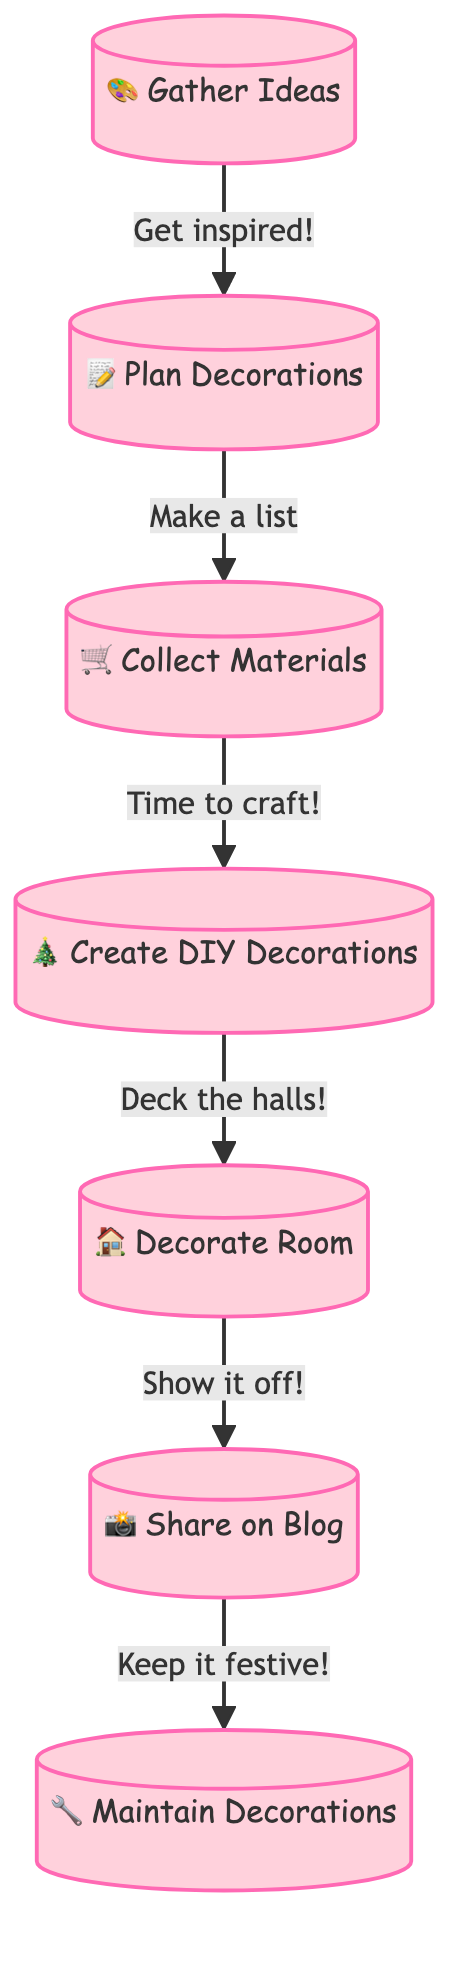What is the first step in the DIY room decoration process? The first block in the diagram is labeled "Gather Ideas," indicating this is the first step in the process.
Answer: Gather Ideas How many blocks are in the diagram? By counting the blocks listed in the data, there are a total of seven blocks showing different stages of the decoration process.
Answer: 7 What action follows "Collect Materials"? Looking at the transitions from one block to another, the action that follows "Collect Materials" is "Create DIY Decorations."
Answer: Create DIY Decorations Which block is directly connected to "Share on Blog"? "Share on Blog" is directly connected to "Maintain Decorations," as indicated by the transition leading from the former to the latter.
Answer: Maintain Decorations What is the last action in the DIY room decoration process? The last action in the block diagram is "Maintain Decorations," which shows it is the final step in the process after sharing on the blog.
Answer: Maintain Decorations Which step involves taking photos? The step where photos are taken is "Share on Blog," as stated in the content of that block, indicating the sharing of the decorated room's images.
Answer: Share on Blog What do you do after decorating the room? After "Decorate Room," the next action is to "Share on Blog," which implies sharing the decorated room experience with others.
Answer: Share on Blog What materials are mentioned for collection? The content of the "Collect Materials" block specifies holiday-themed paper, glue, scissors, paint, and glitter as the materials to be collected.
Answer: holiday-themed paper, glue, scissors, paint, and glitter What is the relationship between "Plan Decorations" and "Gather Ideas"? "Plan Decorations" is the second step that directly follows "Gather Ideas," indicating a sequential relationship of planning after gathering inspiration.
Answer: Plan Decorations 